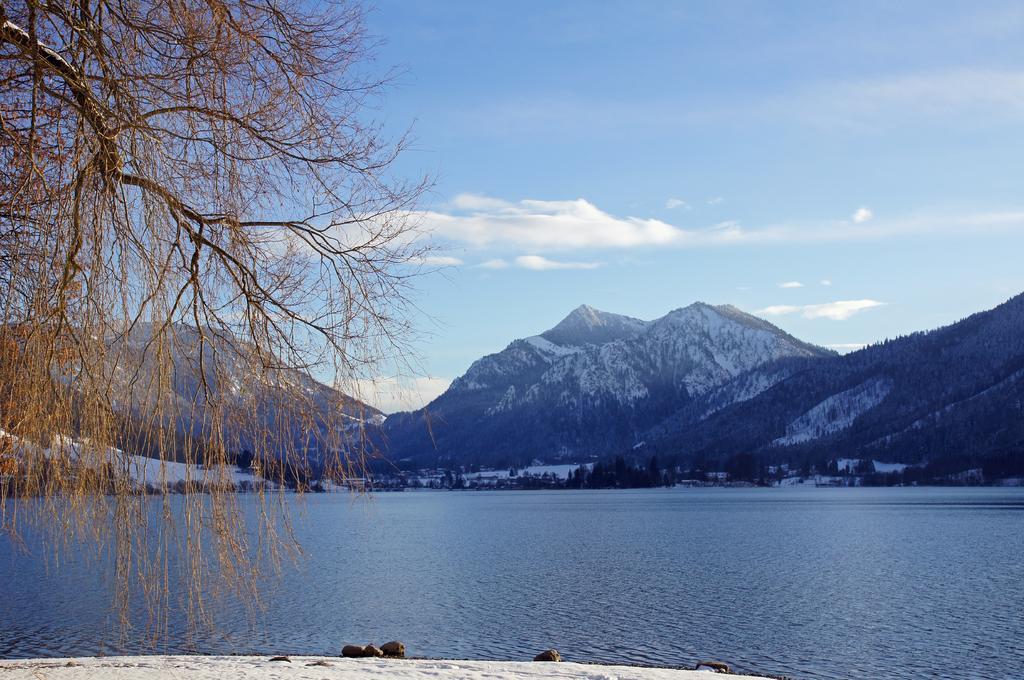Could you give a brief overview of what you see in this image? In the picture we can see a part of the surface with white colored sand and on it we can see some stones and behind it, we can see the water surface which is blue in color and beside it, we can see a part of the tree and far away from the water surface we can see many trees, and mountains with a snow on it and in the background we can see the sky with clouds. 